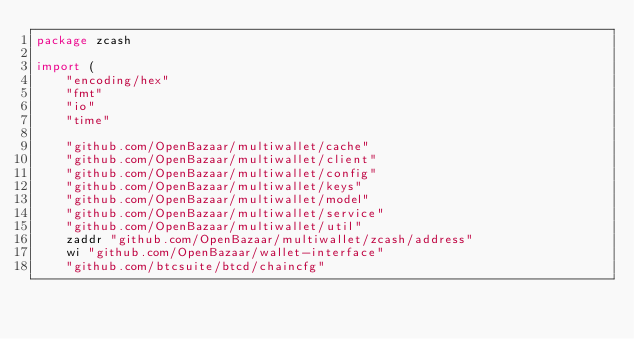Convert code to text. <code><loc_0><loc_0><loc_500><loc_500><_Go_>package zcash

import (
	"encoding/hex"
	"fmt"
	"io"
	"time"

	"github.com/OpenBazaar/multiwallet/cache"
	"github.com/OpenBazaar/multiwallet/client"
	"github.com/OpenBazaar/multiwallet/config"
	"github.com/OpenBazaar/multiwallet/keys"
	"github.com/OpenBazaar/multiwallet/model"
	"github.com/OpenBazaar/multiwallet/service"
	"github.com/OpenBazaar/multiwallet/util"
	zaddr "github.com/OpenBazaar/multiwallet/zcash/address"
	wi "github.com/OpenBazaar/wallet-interface"
	"github.com/btcsuite/btcd/chaincfg"</code> 